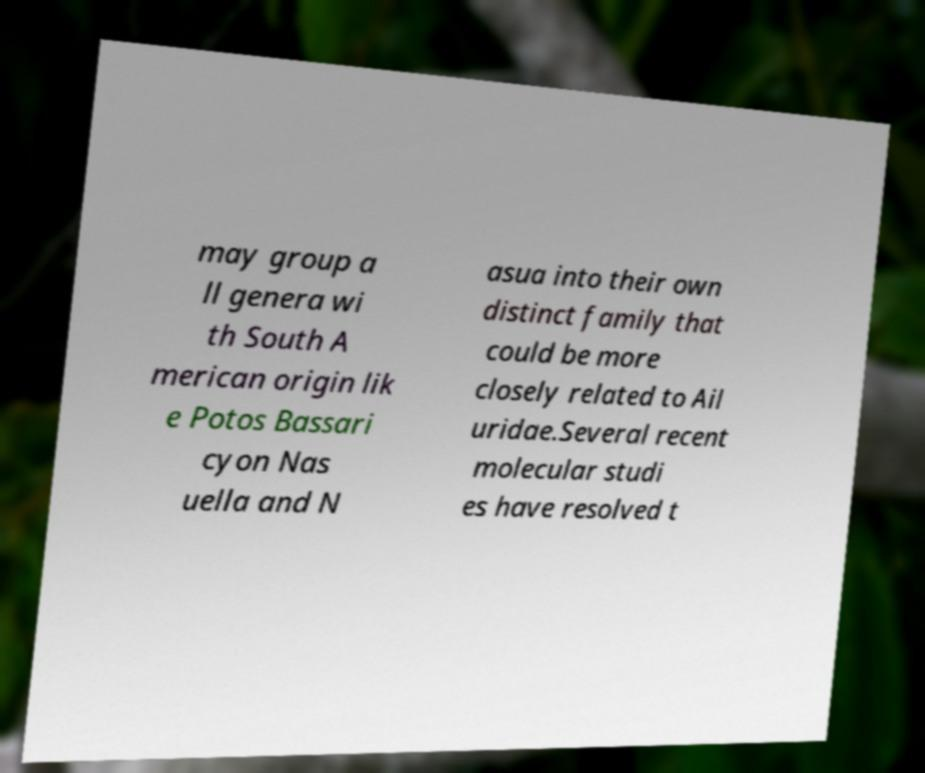Please identify and transcribe the text found in this image. may group a ll genera wi th South A merican origin lik e Potos Bassari cyon Nas uella and N asua into their own distinct family that could be more closely related to Ail uridae.Several recent molecular studi es have resolved t 